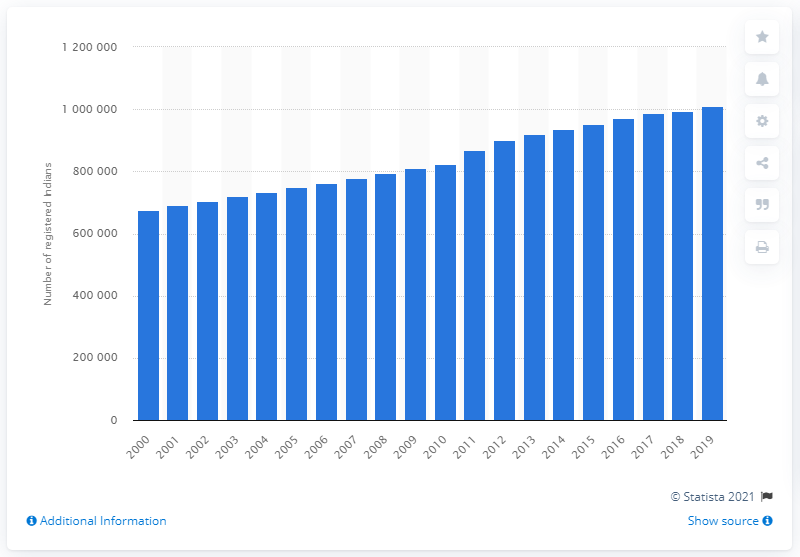Draw attention to some important aspects in this diagram. As of 2019, there were 675,499 registered Indians in Canada. This is a significant number of individuals who have chosen to reside and contribute to the country's economy and culture. In 2000, there were 675,499 registered Indians in Canada. 